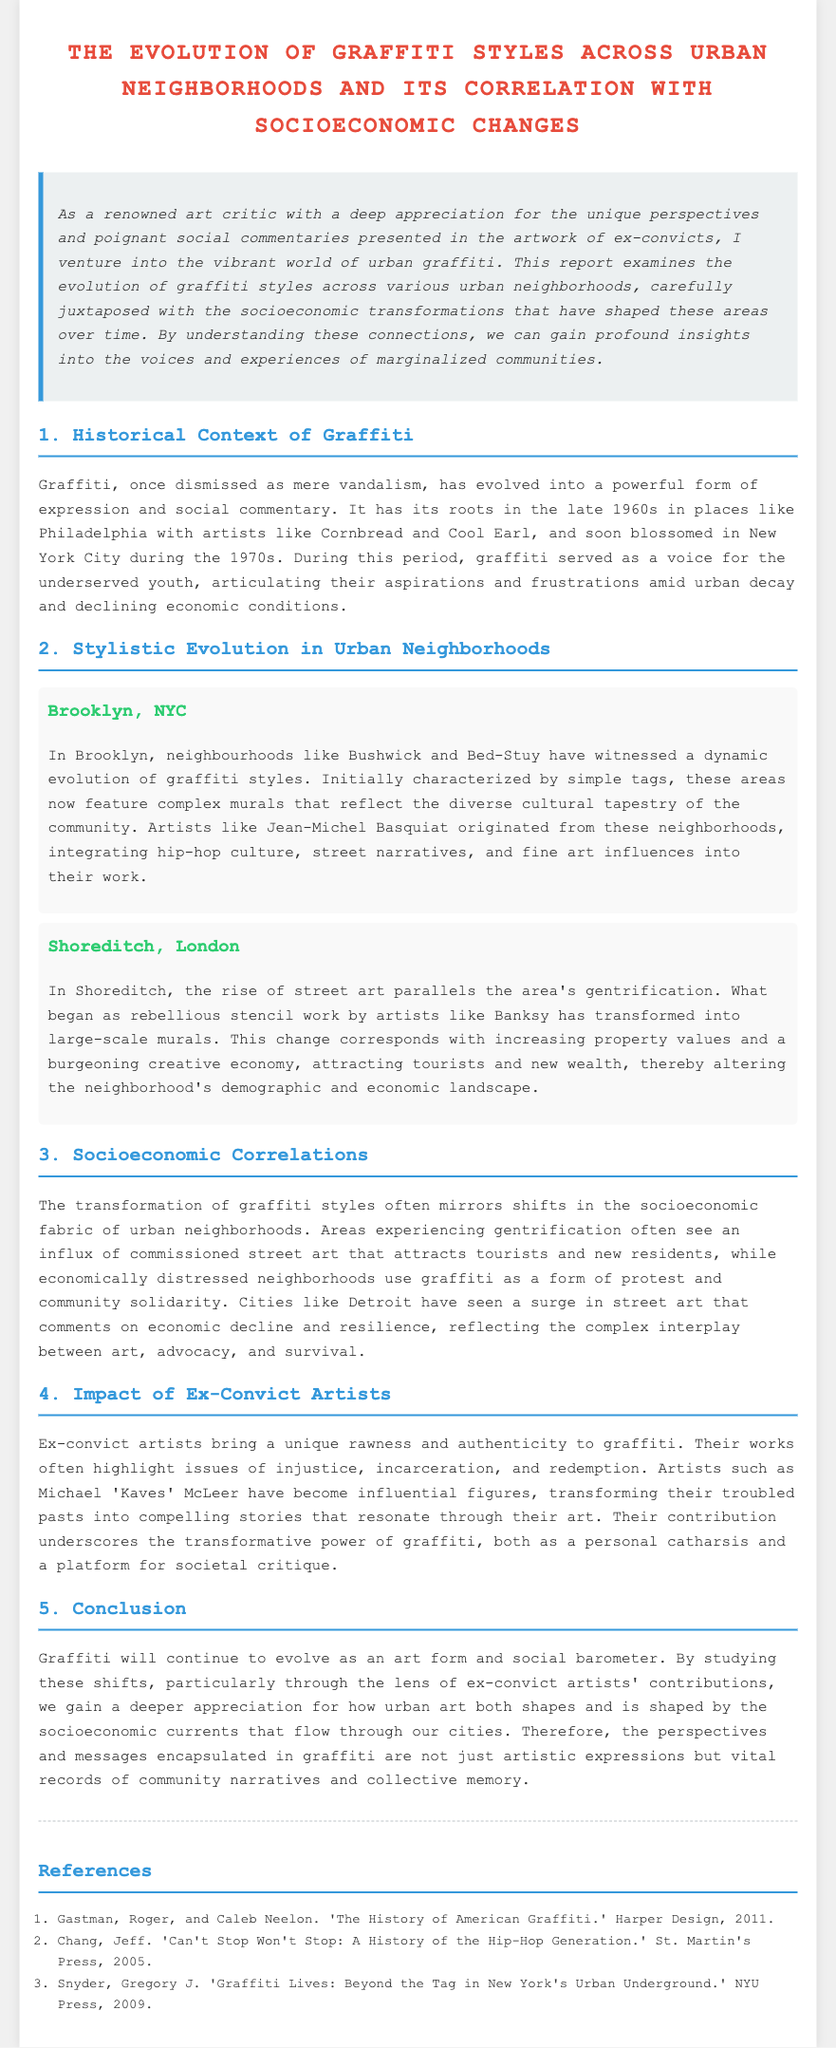What is the historical context of graffiti? The historical context includes its roots in the late 1960s, particularly in Philadelphia, with artists like Cornbread and Cool Earl, and its blossoming in New York City during the 1970s.
Answer: Late 1960s Who is an influential artist associated with Brooklyn's graffiti scene? An influential artist from Brooklyn is Jean-Michel Basquiat, who integrated hip-hop culture and street narratives into his works.
Answer: Jean-Michel Basquiat What neighborhood in London is known for its evolving graffiti styles due to gentrification? Shoreditch, London is known for its evolving graffiti styles that parallel the area's gentrification.
Answer: Shoreditch What is a significant correlation observed in areas experiencing gentrification? In areas experiencing gentrification, there is often an influx of commissioned street art that attracts tourists and new residents.
Answer: Commissioned street art Which ex-convict artist is highlighted for transforming their past into art? Michael "Kaves" McLeer is the ex-convict artist highlighted for transforming his troubled past into compelling stories through his art.
Answer: Michael "Kaves" McLeer What is described as a powerful form of expression and social commentary? Graffiti is described as a powerful form of expression and social commentary that has evolved over time.
Answer: Graffiti How does graffiti serve economically distressed neighborhoods? Graffiti serves as a form of protest and community solidarity in economically distressed neighborhoods.
Answer: Protest and community solidarity What do the perspectives encapsulated in graffiti represent? The perspectives encapsulated in graffiti represent vital records of community narratives and collective memory.
Answer: Vital records of community narratives 